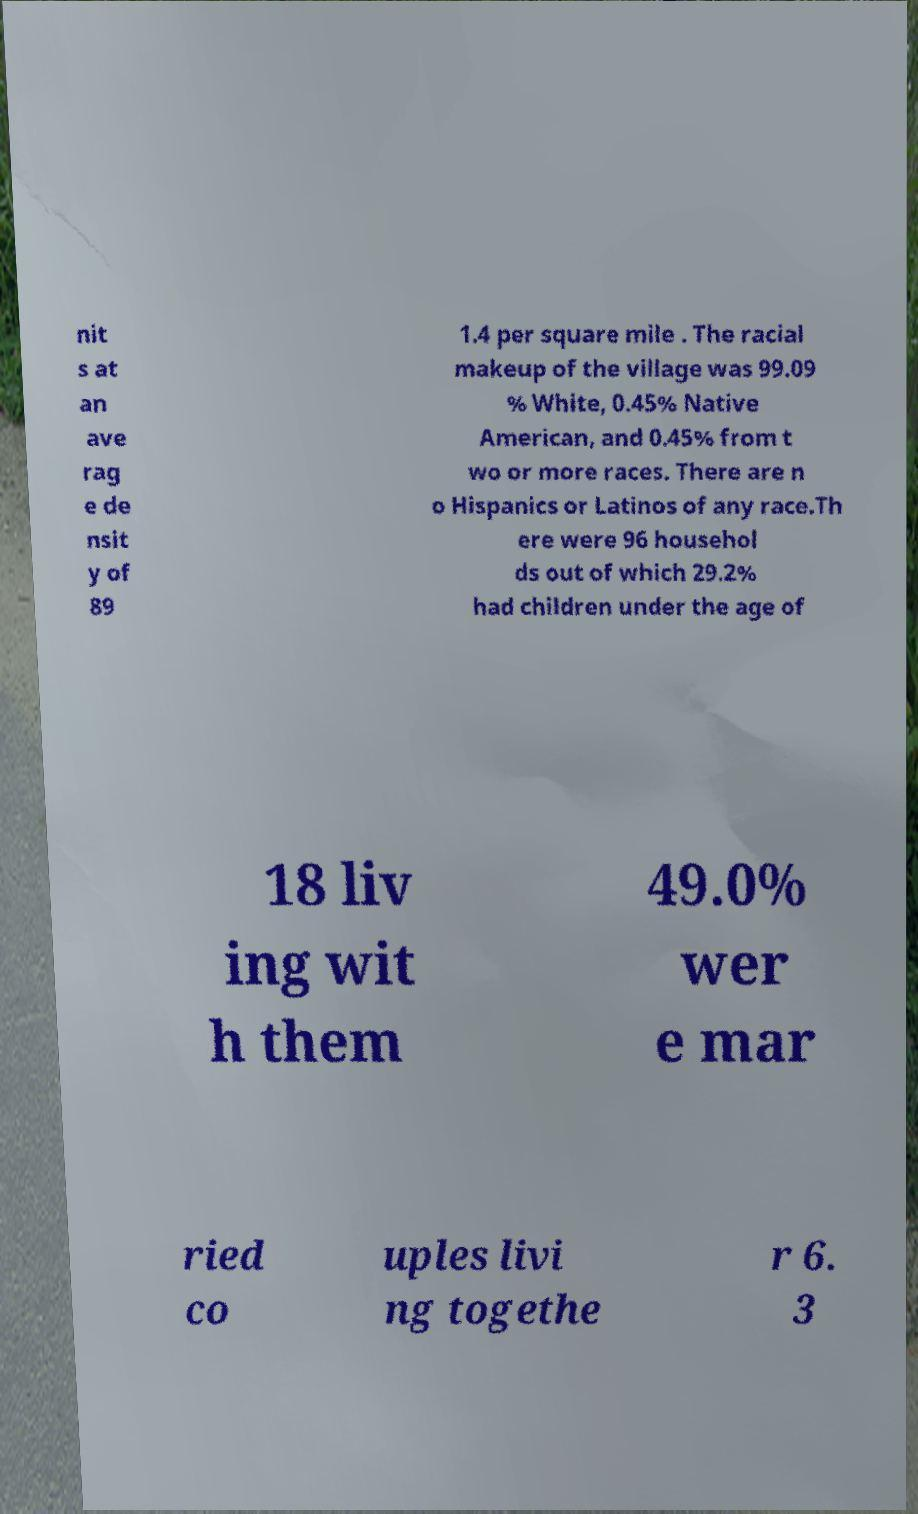There's text embedded in this image that I need extracted. Can you transcribe it verbatim? nit s at an ave rag e de nsit y of 89 1.4 per square mile . The racial makeup of the village was 99.09 % White, 0.45% Native American, and 0.45% from t wo or more races. There are n o Hispanics or Latinos of any race.Th ere were 96 househol ds out of which 29.2% had children under the age of 18 liv ing wit h them 49.0% wer e mar ried co uples livi ng togethe r 6. 3 